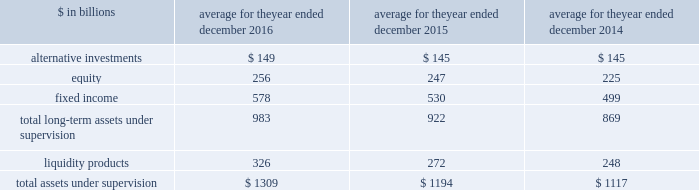The goldman sachs group , inc .
And subsidiaries management 2019s discussion and analysis 2030 total aus net inflows/ ( outflows ) for 2014 includes $ 19 billion of fixed income asset inflows in connection with our acquisition of deutsche asset & wealth management 2019s stable value business and $ 6 billion of liquidity products inflows in connection with our acquisition of rbs asset management 2019s money market funds .
The table below presents our average monthly assets under supervision by asset class .
Average for the year ended december $ in billions 2016 2015 2014 .
Operating environment .
Following a challenging first quarter of 2016 , market conditions continued to improve with higher asset prices resulting in full year appreciation in our client assets in both equity and fixed income assets .
Also , our assets under supervision increased during 2016 from net inflows , primarily in fixed income assets , and liquidity products .
The mix of our average assets under supervision shifted slightly compared with 2015 from long- term assets under supervision to liquidity products .
Management fees have been impacted by many factors , including inflows to advisory services and outflows from actively-managed mutual funds .
In the future , if asset prices decline , or investors continue the trend of favoring assets that typically generate lower fees or investors withdraw their assets , net revenues in investment management would likely be negatively impacted .
During 2015 , investment management operated in an environment generally characterized by strong client net inflows , which more than offset the declines in equity and fixed income asset prices , which resulted in depreciation in the value of client assets , particularly in the third quarter of 2015 .
The mix of average assets under supervision shifted slightly from long-term assets under supervision to liquidity products compared with 2014 .
2016 versus 2015 .
Net revenues in investment management were $ 5.79 billion for 2016 , 7% ( 7 % ) lower than 2015 .
This decrease primarily reflected significantly lower incentive fees compared with a strong 2015 .
In addition , management and other fees were slightly lower , reflecting shifts in the mix of client assets and strategies , partially offset by the impact of higher average assets under supervision .
During the year , total assets under supervision increased $ 127 billion to $ 1.38 trillion .
Long-term assets under supervision increased $ 75 billion , including net inflows of $ 42 billion , primarily in fixed income assets , and net market appreciation of $ 33 billion , primarily in equity and fixed income assets .
In addition , liquidity products increased $ 52 billion .
Operating expenses were $ 4.65 billion for 2016 , 4% ( 4 % ) lower than 2015 , due to decreased compensation and benefits expenses , reflecting lower net revenues .
Pre-tax earnings were $ 1.13 billion in 2016 , 17% ( 17 % ) lower than 2015 .
2015 versus 2014 .
Net revenues in investment management were $ 6.21 billion for 2015 , 3% ( 3 % ) higher than 2014 , due to slightly higher management and other fees , primarily reflecting higher average assets under supervision , and higher transaction revenues .
During 2015 , total assets under supervision increased $ 74 billion to $ 1.25 trillion .
Long-term assets under supervision increased $ 51 billion , including net inflows of $ 71 billion ( which includes $ 18 billion of asset inflows in connection with our acquisition of pacific global advisors 2019 solutions business ) , and net market depreciation of $ 20 billion , both primarily in fixed income and equity assets .
In addition , liquidity products increased $ 23 billion .
Operating expenses were $ 4.84 billion for 2015 , 4% ( 4 % ) higher than 2014 , due to increased compensation and benefits expenses , reflecting higher net revenues .
Pre-tax earnings were $ 1.37 billion in 2015 , 2% ( 2 % ) lower than 2014 .
Geographic data see note 25 to the consolidated financial statements for a summary of our total net revenues , pre-tax earnings and net earnings by geographic region .
Goldman sachs 2016 form 10-k 65 .
What percentage of total long-term assets under supervision are comprised of fixed income in 2015? 
Computations: (530 / 922)
Answer: 0.57484. The goldman sachs group , inc .
And subsidiaries management 2019s discussion and analysis 2030 total aus net inflows/ ( outflows ) for 2014 includes $ 19 billion of fixed income asset inflows in connection with our acquisition of deutsche asset & wealth management 2019s stable value business and $ 6 billion of liquidity products inflows in connection with our acquisition of rbs asset management 2019s money market funds .
The table below presents our average monthly assets under supervision by asset class .
Average for the year ended december $ in billions 2016 2015 2014 .
Operating environment .
Following a challenging first quarter of 2016 , market conditions continued to improve with higher asset prices resulting in full year appreciation in our client assets in both equity and fixed income assets .
Also , our assets under supervision increased during 2016 from net inflows , primarily in fixed income assets , and liquidity products .
The mix of our average assets under supervision shifted slightly compared with 2015 from long- term assets under supervision to liquidity products .
Management fees have been impacted by many factors , including inflows to advisory services and outflows from actively-managed mutual funds .
In the future , if asset prices decline , or investors continue the trend of favoring assets that typically generate lower fees or investors withdraw their assets , net revenues in investment management would likely be negatively impacted .
During 2015 , investment management operated in an environment generally characterized by strong client net inflows , which more than offset the declines in equity and fixed income asset prices , which resulted in depreciation in the value of client assets , particularly in the third quarter of 2015 .
The mix of average assets under supervision shifted slightly from long-term assets under supervision to liquidity products compared with 2014 .
2016 versus 2015 .
Net revenues in investment management were $ 5.79 billion for 2016 , 7% ( 7 % ) lower than 2015 .
This decrease primarily reflected significantly lower incentive fees compared with a strong 2015 .
In addition , management and other fees were slightly lower , reflecting shifts in the mix of client assets and strategies , partially offset by the impact of higher average assets under supervision .
During the year , total assets under supervision increased $ 127 billion to $ 1.38 trillion .
Long-term assets under supervision increased $ 75 billion , including net inflows of $ 42 billion , primarily in fixed income assets , and net market appreciation of $ 33 billion , primarily in equity and fixed income assets .
In addition , liquidity products increased $ 52 billion .
Operating expenses were $ 4.65 billion for 2016 , 4% ( 4 % ) lower than 2015 , due to decreased compensation and benefits expenses , reflecting lower net revenues .
Pre-tax earnings were $ 1.13 billion in 2016 , 17% ( 17 % ) lower than 2015 .
2015 versus 2014 .
Net revenues in investment management were $ 6.21 billion for 2015 , 3% ( 3 % ) higher than 2014 , due to slightly higher management and other fees , primarily reflecting higher average assets under supervision , and higher transaction revenues .
During 2015 , total assets under supervision increased $ 74 billion to $ 1.25 trillion .
Long-term assets under supervision increased $ 51 billion , including net inflows of $ 71 billion ( which includes $ 18 billion of asset inflows in connection with our acquisition of pacific global advisors 2019 solutions business ) , and net market depreciation of $ 20 billion , both primarily in fixed income and equity assets .
In addition , liquidity products increased $ 23 billion .
Operating expenses were $ 4.84 billion for 2015 , 4% ( 4 % ) higher than 2014 , due to increased compensation and benefits expenses , reflecting higher net revenues .
Pre-tax earnings were $ 1.37 billion in 2015 , 2% ( 2 % ) lower than 2014 .
Geographic data see note 25 to the consolidated financial statements for a summary of our total net revenues , pre-tax earnings and net earnings by geographic region .
Goldman sachs 2016 form 10-k 65 .
What percentage of total long-term assets under supervision are comprised of fixed income in 2016? 
Computations: (578 / 983)
Answer: 0.588. The goldman sachs group , inc .
And subsidiaries management 2019s discussion and analysis 2030 total aus net inflows/ ( outflows ) for 2014 includes $ 19 billion of fixed income asset inflows in connection with our acquisition of deutsche asset & wealth management 2019s stable value business and $ 6 billion of liquidity products inflows in connection with our acquisition of rbs asset management 2019s money market funds .
The table below presents our average monthly assets under supervision by asset class .
Average for the year ended december $ in billions 2016 2015 2014 .
Operating environment .
Following a challenging first quarter of 2016 , market conditions continued to improve with higher asset prices resulting in full year appreciation in our client assets in both equity and fixed income assets .
Also , our assets under supervision increased during 2016 from net inflows , primarily in fixed income assets , and liquidity products .
The mix of our average assets under supervision shifted slightly compared with 2015 from long- term assets under supervision to liquidity products .
Management fees have been impacted by many factors , including inflows to advisory services and outflows from actively-managed mutual funds .
In the future , if asset prices decline , or investors continue the trend of favoring assets that typically generate lower fees or investors withdraw their assets , net revenues in investment management would likely be negatively impacted .
During 2015 , investment management operated in an environment generally characterized by strong client net inflows , which more than offset the declines in equity and fixed income asset prices , which resulted in depreciation in the value of client assets , particularly in the third quarter of 2015 .
The mix of average assets under supervision shifted slightly from long-term assets under supervision to liquidity products compared with 2014 .
2016 versus 2015 .
Net revenues in investment management were $ 5.79 billion for 2016 , 7% ( 7 % ) lower than 2015 .
This decrease primarily reflected significantly lower incentive fees compared with a strong 2015 .
In addition , management and other fees were slightly lower , reflecting shifts in the mix of client assets and strategies , partially offset by the impact of higher average assets under supervision .
During the year , total assets under supervision increased $ 127 billion to $ 1.38 trillion .
Long-term assets under supervision increased $ 75 billion , including net inflows of $ 42 billion , primarily in fixed income assets , and net market appreciation of $ 33 billion , primarily in equity and fixed income assets .
In addition , liquidity products increased $ 52 billion .
Operating expenses were $ 4.65 billion for 2016 , 4% ( 4 % ) lower than 2015 , due to decreased compensation and benefits expenses , reflecting lower net revenues .
Pre-tax earnings were $ 1.13 billion in 2016 , 17% ( 17 % ) lower than 2015 .
2015 versus 2014 .
Net revenues in investment management were $ 6.21 billion for 2015 , 3% ( 3 % ) higher than 2014 , due to slightly higher management and other fees , primarily reflecting higher average assets under supervision , and higher transaction revenues .
During 2015 , total assets under supervision increased $ 74 billion to $ 1.25 trillion .
Long-term assets under supervision increased $ 51 billion , including net inflows of $ 71 billion ( which includes $ 18 billion of asset inflows in connection with our acquisition of pacific global advisors 2019 solutions business ) , and net market depreciation of $ 20 billion , both primarily in fixed income and equity assets .
In addition , liquidity products increased $ 23 billion .
Operating expenses were $ 4.84 billion for 2015 , 4% ( 4 % ) higher than 2014 , due to increased compensation and benefits expenses , reflecting higher net revenues .
Pre-tax earnings were $ 1.37 billion in 2015 , 2% ( 2 % ) lower than 2014 .
Geographic data see note 25 to the consolidated financial statements for a summary of our total net revenues , pre-tax earnings and net earnings by geographic region .
Goldman sachs 2016 form 10-k 65 .
In billions , for 2016 , 2015 , and 2014 , what are total alternative investments? 
Computations: table_sum(alternative investments, none)
Answer: 439.0. 